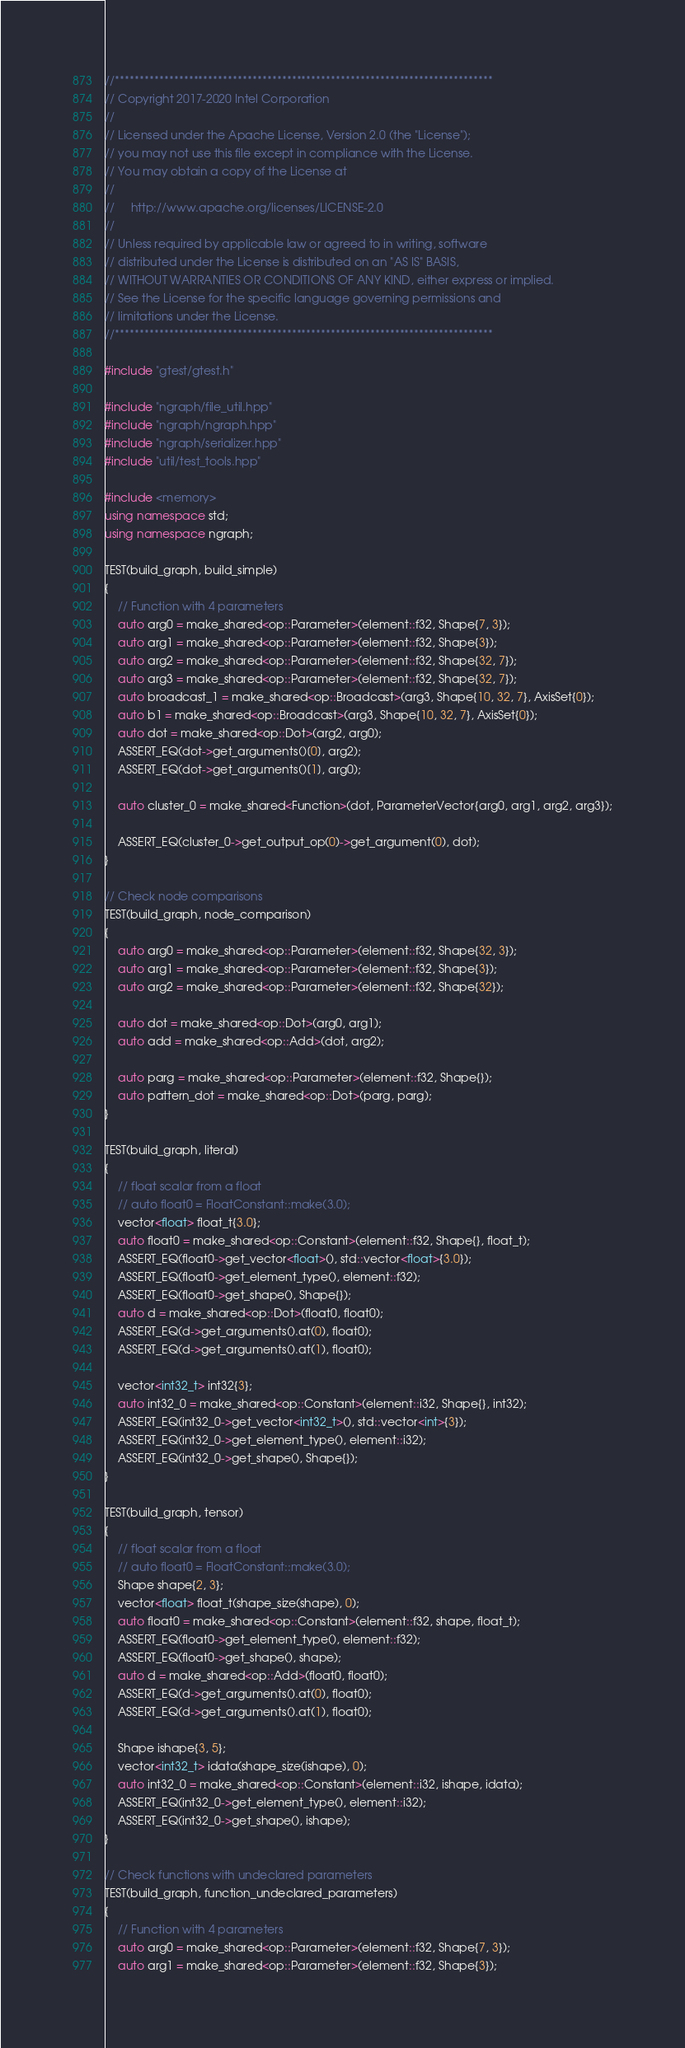<code> <loc_0><loc_0><loc_500><loc_500><_C++_>//*****************************************************************************
// Copyright 2017-2020 Intel Corporation
//
// Licensed under the Apache License, Version 2.0 (the "License");
// you may not use this file except in compliance with the License.
// You may obtain a copy of the License at
//
//     http://www.apache.org/licenses/LICENSE-2.0
//
// Unless required by applicable law or agreed to in writing, software
// distributed under the License is distributed on an "AS IS" BASIS,
// WITHOUT WARRANTIES OR CONDITIONS OF ANY KIND, either express or implied.
// See the License for the specific language governing permissions and
// limitations under the License.
//*****************************************************************************

#include "gtest/gtest.h"

#include "ngraph/file_util.hpp"
#include "ngraph/ngraph.hpp"
#include "ngraph/serializer.hpp"
#include "util/test_tools.hpp"

#include <memory>
using namespace std;
using namespace ngraph;

TEST(build_graph, build_simple)
{
    // Function with 4 parameters
    auto arg0 = make_shared<op::Parameter>(element::f32, Shape{7, 3});
    auto arg1 = make_shared<op::Parameter>(element::f32, Shape{3});
    auto arg2 = make_shared<op::Parameter>(element::f32, Shape{32, 7});
    auto arg3 = make_shared<op::Parameter>(element::f32, Shape{32, 7});
    auto broadcast_1 = make_shared<op::Broadcast>(arg3, Shape{10, 32, 7}, AxisSet{0});
    auto b1 = make_shared<op::Broadcast>(arg3, Shape{10, 32, 7}, AxisSet{0});
    auto dot = make_shared<op::Dot>(arg2, arg0);
    ASSERT_EQ(dot->get_arguments()[0], arg2);
    ASSERT_EQ(dot->get_arguments()[1], arg0);

    auto cluster_0 = make_shared<Function>(dot, ParameterVector{arg0, arg1, arg2, arg3});

    ASSERT_EQ(cluster_0->get_output_op(0)->get_argument(0), dot);
}

// Check node comparisons
TEST(build_graph, node_comparison)
{
    auto arg0 = make_shared<op::Parameter>(element::f32, Shape{32, 3});
    auto arg1 = make_shared<op::Parameter>(element::f32, Shape{3});
    auto arg2 = make_shared<op::Parameter>(element::f32, Shape{32});

    auto dot = make_shared<op::Dot>(arg0, arg1);
    auto add = make_shared<op::Add>(dot, arg2);

    auto parg = make_shared<op::Parameter>(element::f32, Shape{});
    auto pattern_dot = make_shared<op::Dot>(parg, parg);
}

TEST(build_graph, literal)
{
    // float scalar from a float
    // auto float0 = FloatConstant::make(3.0);
    vector<float> float_t{3.0};
    auto float0 = make_shared<op::Constant>(element::f32, Shape{}, float_t);
    ASSERT_EQ(float0->get_vector<float>(), std::vector<float>{3.0});
    ASSERT_EQ(float0->get_element_type(), element::f32);
    ASSERT_EQ(float0->get_shape(), Shape{});
    auto d = make_shared<op::Dot>(float0, float0);
    ASSERT_EQ(d->get_arguments().at(0), float0);
    ASSERT_EQ(d->get_arguments().at(1), float0);

    vector<int32_t> int32{3};
    auto int32_0 = make_shared<op::Constant>(element::i32, Shape{}, int32);
    ASSERT_EQ(int32_0->get_vector<int32_t>(), std::vector<int>{3});
    ASSERT_EQ(int32_0->get_element_type(), element::i32);
    ASSERT_EQ(int32_0->get_shape(), Shape{});
}

TEST(build_graph, tensor)
{
    // float scalar from a float
    // auto float0 = FloatConstant::make(3.0);
    Shape shape{2, 3};
    vector<float> float_t(shape_size(shape), 0);
    auto float0 = make_shared<op::Constant>(element::f32, shape, float_t);
    ASSERT_EQ(float0->get_element_type(), element::f32);
    ASSERT_EQ(float0->get_shape(), shape);
    auto d = make_shared<op::Add>(float0, float0);
    ASSERT_EQ(d->get_arguments().at(0), float0);
    ASSERT_EQ(d->get_arguments().at(1), float0);

    Shape ishape{3, 5};
    vector<int32_t> idata(shape_size(ishape), 0);
    auto int32_0 = make_shared<op::Constant>(element::i32, ishape, idata);
    ASSERT_EQ(int32_0->get_element_type(), element::i32);
    ASSERT_EQ(int32_0->get_shape(), ishape);
}

// Check functions with undeclared parameters
TEST(build_graph, function_undeclared_parameters)
{
    // Function with 4 parameters
    auto arg0 = make_shared<op::Parameter>(element::f32, Shape{7, 3});
    auto arg1 = make_shared<op::Parameter>(element::f32, Shape{3});</code> 